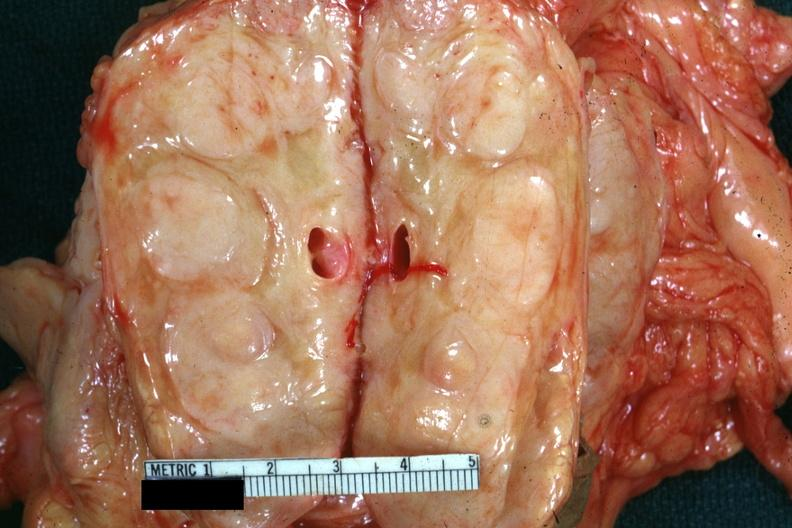what showing massively enlarged nodes very good example was diagnosed as reticulum cell sarcoma?
Answer the question using a single word or phrase. Cut edge of mesentery 